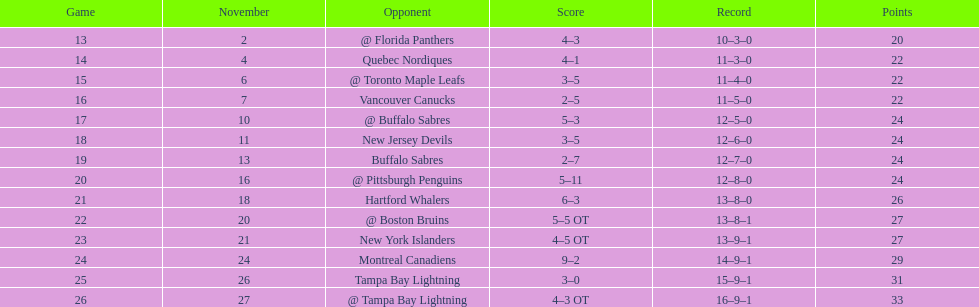What were the point totals? @ Florida Panthers, 4–3, Quebec Nordiques, 4–1, @ Toronto Maple Leafs, 3–5, Vancouver Canucks, 2–5, @ Buffalo Sabres, 5–3, New Jersey Devils, 3–5, Buffalo Sabres, 2–7, @ Pittsburgh Penguins, 5–11, Hartford Whalers, 6–3, @ Boston Bruins, 5–5 OT, New York Islanders, 4–5 OT, Montreal Canadiens, 9–2, Tampa Bay Lightning, 3–0, @ Tampa Bay Lightning, 4–3 OT. Which score was nearest? New York Islanders, 4–5 OT. Which team achieved that score? New York Islanders. 